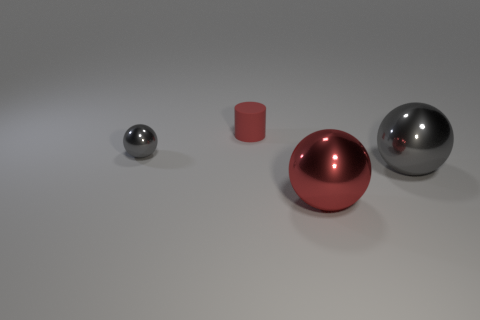There is a gray shiny thing that is behind the gray thing that is to the right of the tiny gray metallic ball; how many rubber objects are behind it?
Your response must be concise. 1. Is the number of things on the right side of the red metallic ball less than the number of small rubber things that are behind the small shiny thing?
Make the answer very short. No. What number of other objects are the same material as the red cylinder?
Provide a succinct answer. 0. There is a ball that is the same size as the matte thing; what is its material?
Give a very brief answer. Metal. How many brown things are either balls or tiny cylinders?
Your response must be concise. 0. The metallic sphere that is both behind the large red metal object and on the right side of the red rubber cylinder is what color?
Your answer should be compact. Gray. Is the material of the tiny object on the left side of the small red cylinder the same as the gray ball that is on the right side of the matte object?
Provide a short and direct response. Yes. Are there more gray things right of the red cylinder than gray metal spheres on the right side of the large gray ball?
Make the answer very short. Yes. How many things are small matte cylinders or metallic things that are on the right side of the small gray thing?
Provide a short and direct response. 3. Do the matte cylinder and the tiny sphere have the same color?
Make the answer very short. No. 